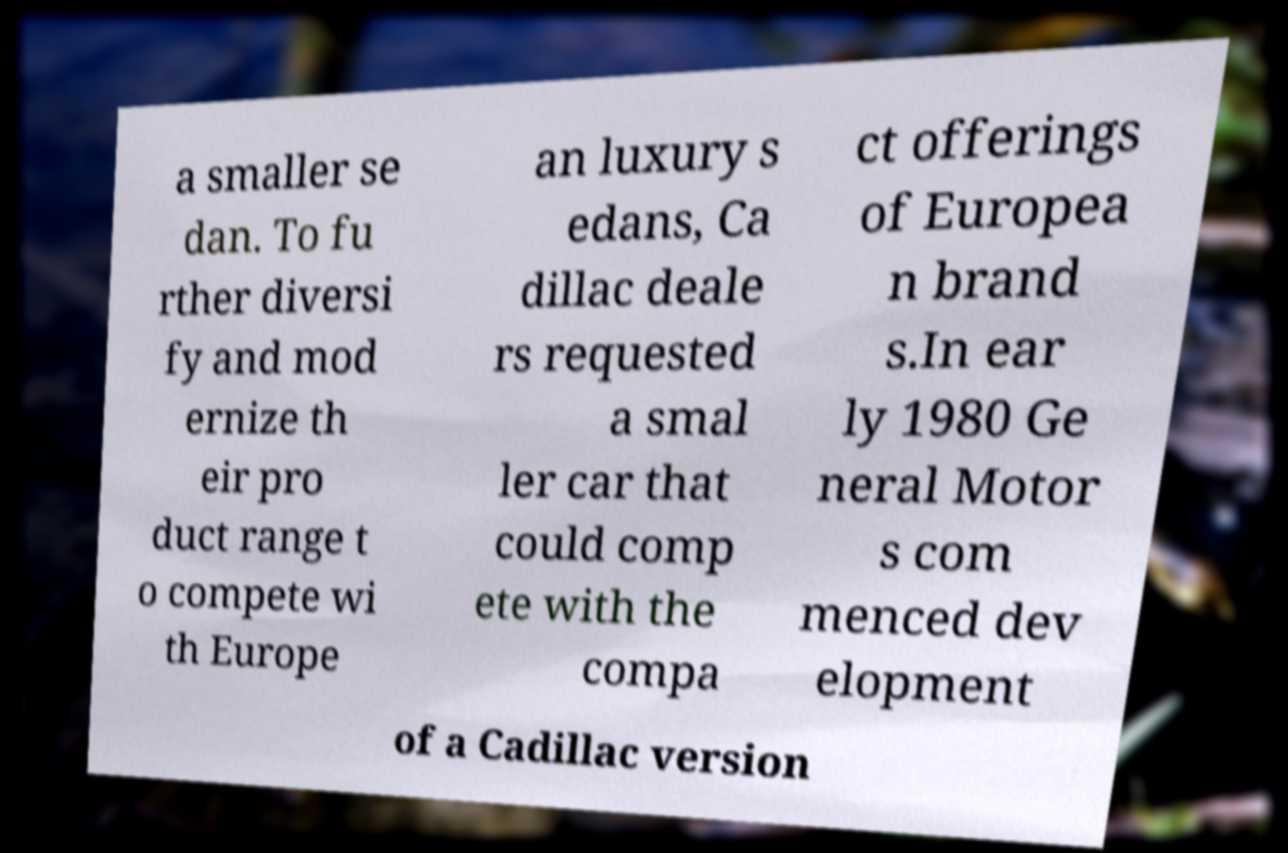There's text embedded in this image that I need extracted. Can you transcribe it verbatim? a smaller se dan. To fu rther diversi fy and mod ernize th eir pro duct range t o compete wi th Europe an luxury s edans, Ca dillac deale rs requested a smal ler car that could comp ete with the compa ct offerings of Europea n brand s.In ear ly 1980 Ge neral Motor s com menced dev elopment of a Cadillac version 